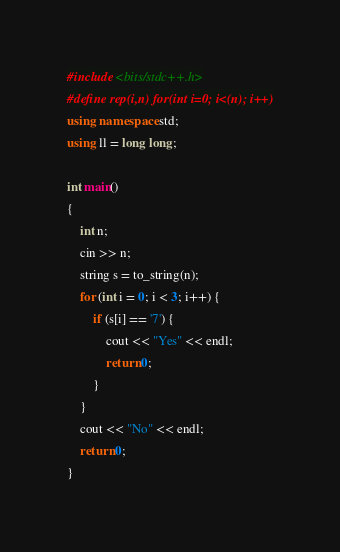Convert code to text. <code><loc_0><loc_0><loc_500><loc_500><_C++_>#include <bits/stdc++.h>
#define rep(i,n) for(int i=0; i<(n); i++)
using namespace std;
using ll = long long;

int main()
{
    int n;
    cin >> n;
    string s = to_string(n);
    for (int i = 0; i < 3; i++) {
        if (s[i] == '7') {
            cout << "Yes" << endl;
            return 0;
        }
    }
    cout << "No" << endl;
    return 0;
}</code> 